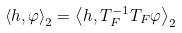<formula> <loc_0><loc_0><loc_500><loc_500>\left \langle h , \varphi \right \rangle _ { 2 } = \left \langle h , T _ { F } ^ { - 1 } T _ { F } \varphi \right \rangle _ { 2 }</formula> 